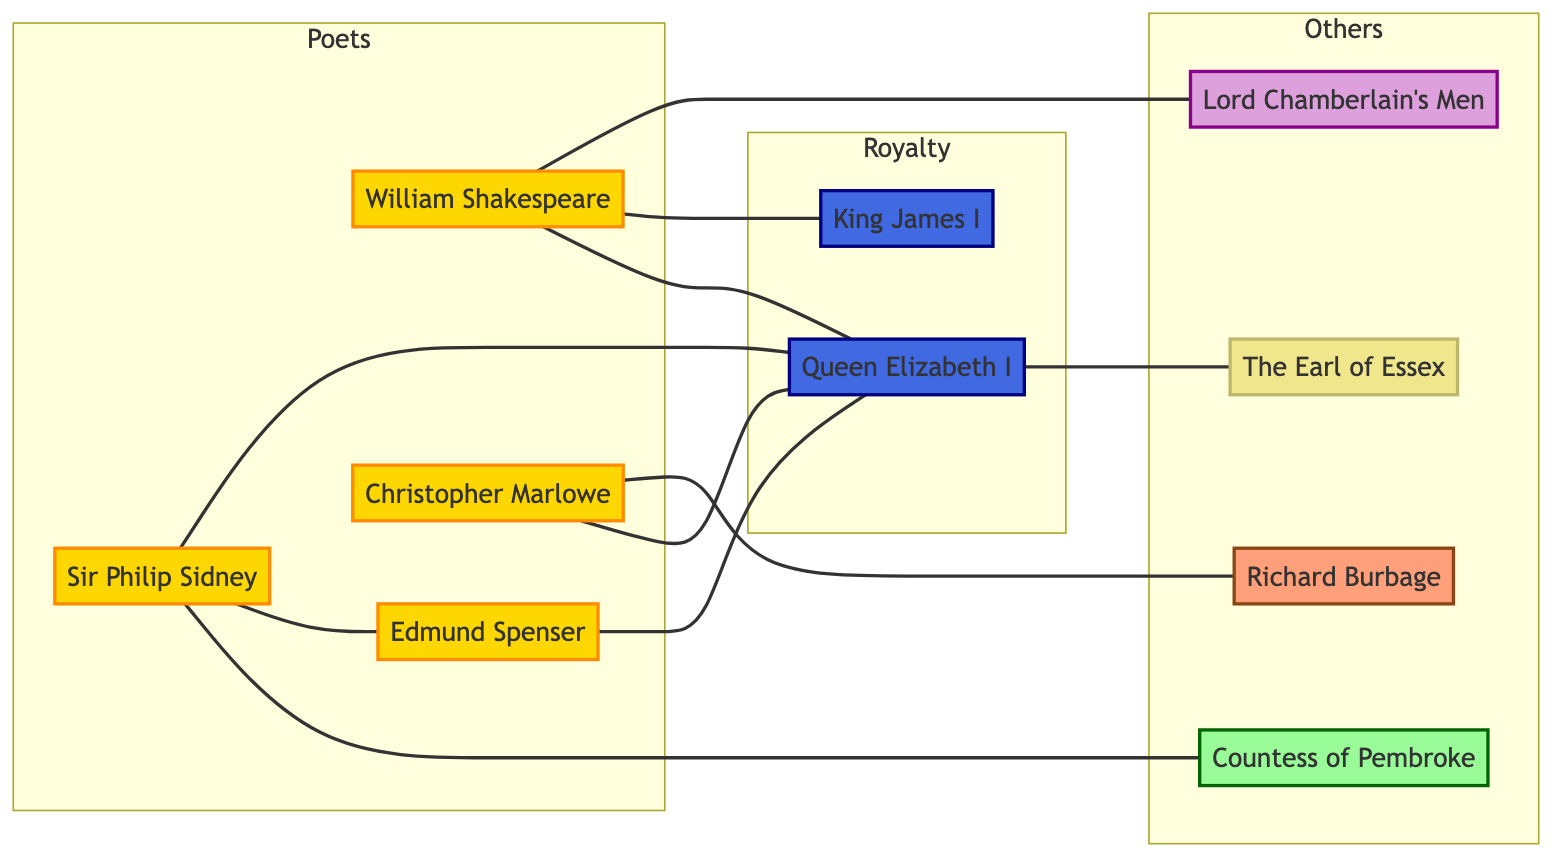What is the total number of nodes in the graph? The diagram lists ten nodes, which represent various figures in the socio-political landscape of Renaissance poetry.
Answer: 10 Who is connected to the Countess of Pembroke? The only connection shown in the diagram is between Sir Philip Sidney and the Countess of Pembroke, indicating a sibling relationship.
Answer: Sir Philip Sidney What is the type of relationship between William Shakespeare and Queen Elizabeth I? The edge between William Shakespeare and Queen Elizabeth I indicates an "influence" relationship, signifying her impact on his work or career.
Answer: influence How many poets are depicted in the graph? The diagram shows four distinct poets: William Shakespeare, Sir Philip Sidney, Edmund Spenser, and Christopher Marlowe, thus totaling four poets.
Answer: 4 Which monarch is connected to both William Shakespeare and Christopher Marlowe? The diagram shows that both William Shakespeare and Christopher Marlowe have edges connecting them to Queen Elizabeth I, indicating her influence over both.
Answer: Queen Elizabeth I Who are the two monarchs depicted in the graph? The graph includes two monarchs, Queen Elizabeth I and King James I, illustrated in the 'Royalty' subgraph.
Answer: Queen Elizabeth I, King James I What type of organization is Lord Chamberlain's Men in the graph? The diagram categorizes Lord Chamberlain's Men as a "theater company," indicated under the 'Others' subgraph.
Answer: theater company Which poet had a collaboration with Richard Burbage? The diagram clearly shows Christopher Marlowe's collaboration with actor Richard Burbage.
Answer: Christopher Marlowe What type of relationship does Sir Philip Sidney have with Edmund Spenser? There is a "friendship" relationship represented by an edge connecting Sir Philip Sidney to Edmund Spenser in the diagram.
Answer: friendship 